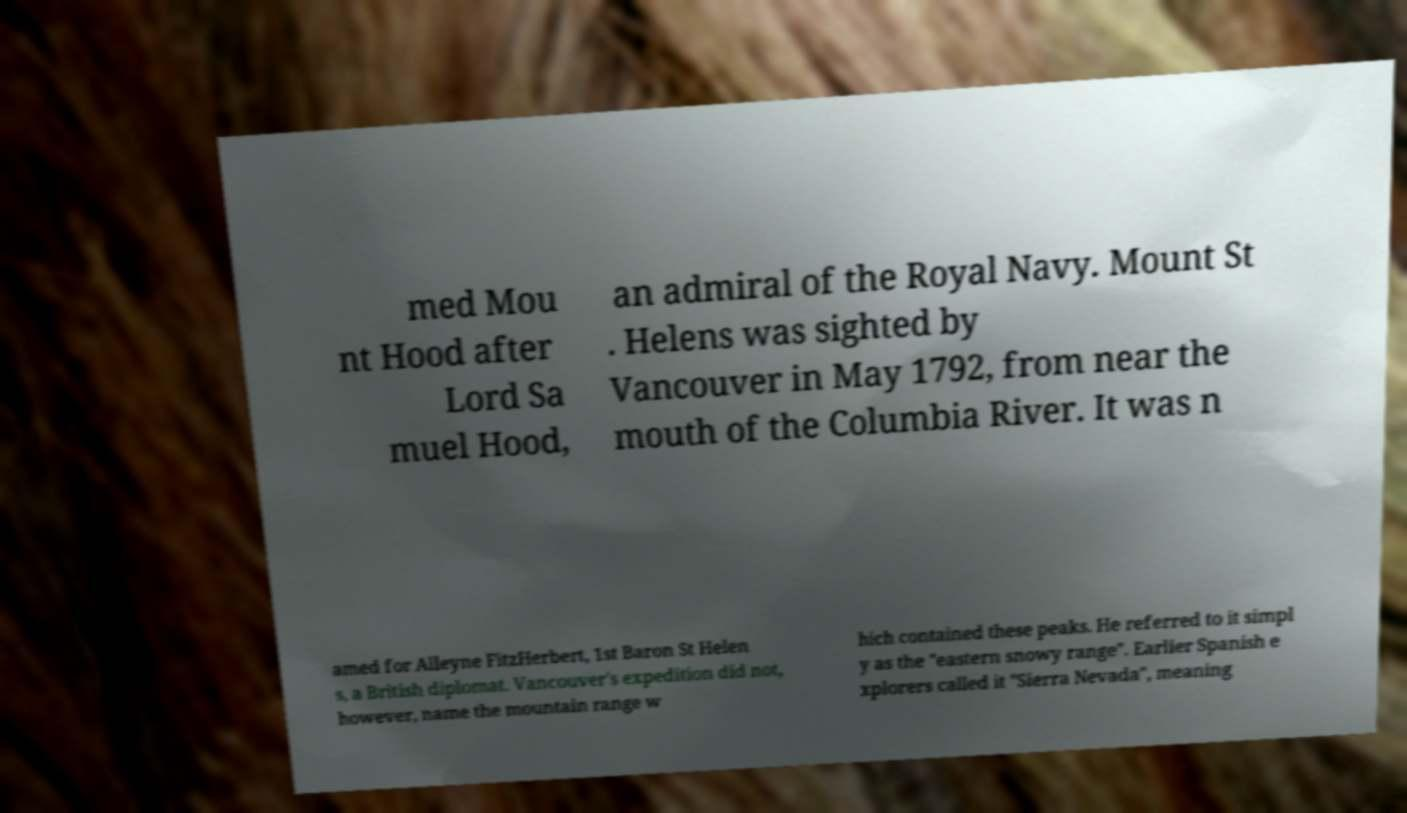There's text embedded in this image that I need extracted. Can you transcribe it verbatim? med Mou nt Hood after Lord Sa muel Hood, an admiral of the Royal Navy. Mount St . Helens was sighted by Vancouver in May 1792, from near the mouth of the Columbia River. It was n amed for Alleyne FitzHerbert, 1st Baron St Helen s, a British diplomat. Vancouver's expedition did not, however, name the mountain range w hich contained these peaks. He referred to it simpl y as the "eastern snowy range". Earlier Spanish e xplorers called it "Sierra Nevada", meaning 